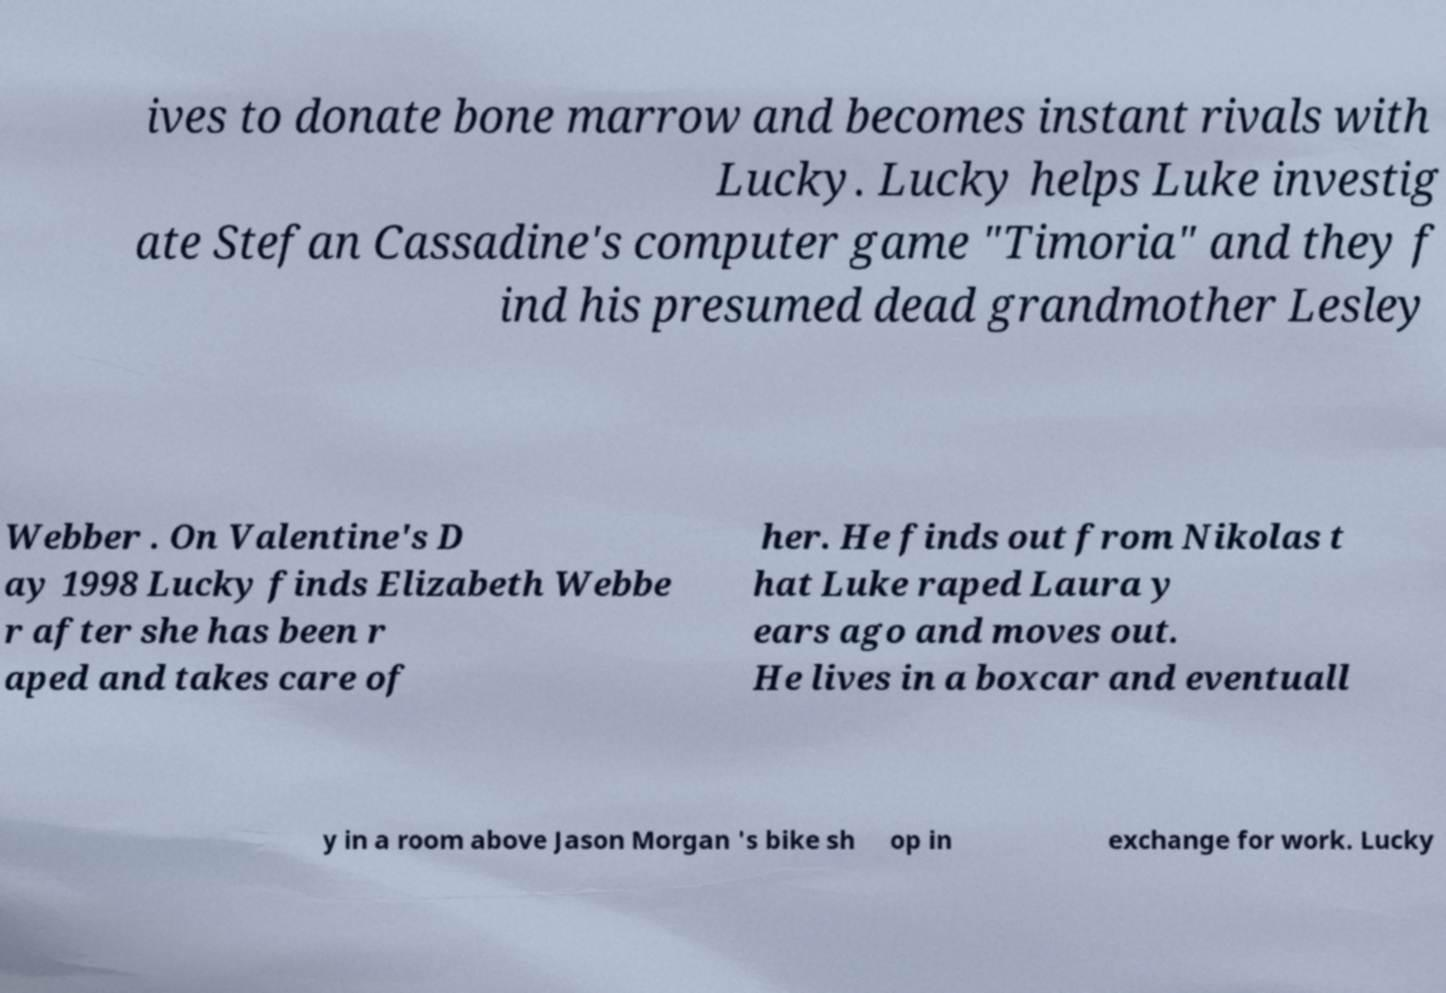For documentation purposes, I need the text within this image transcribed. Could you provide that? ives to donate bone marrow and becomes instant rivals with Lucky. Lucky helps Luke investig ate Stefan Cassadine's computer game "Timoria" and they f ind his presumed dead grandmother Lesley Webber . On Valentine's D ay 1998 Lucky finds Elizabeth Webbe r after she has been r aped and takes care of her. He finds out from Nikolas t hat Luke raped Laura y ears ago and moves out. He lives in a boxcar and eventuall y in a room above Jason Morgan 's bike sh op in exchange for work. Lucky 